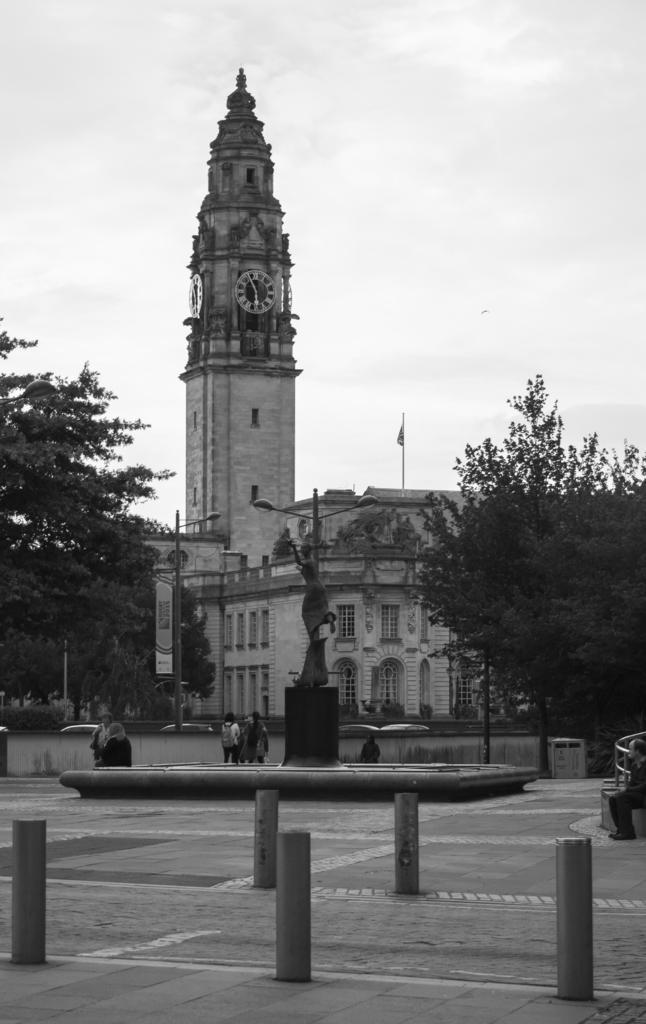What objects can be seen on the pavement in the foreground of the image? There are bollards on the pavement in the foreground of the image. What is located near the bollards in the foreground of the image? There is a statue in the foreground of the image. What are the people in the foreground of the image doing? There are persons sitting and standing in the foreground of the image. What other objects can be seen in the foreground of the image? There are poles and trees in the foreground of the image. What is attached to one of the poles in the foreground of the image? There is a flag in the foreground of the image. What can be seen in the background of the image? There is a building and clouds visible in the image. What type of hook can be seen attached to the building in the image? There is no hook visible in the image; only a flag is attached to one of the poles in the foreground. What kind of apparatus is being used by the persons in the image? There is no apparatus visible in the image; the persons are sitting and standing without any equipment. 